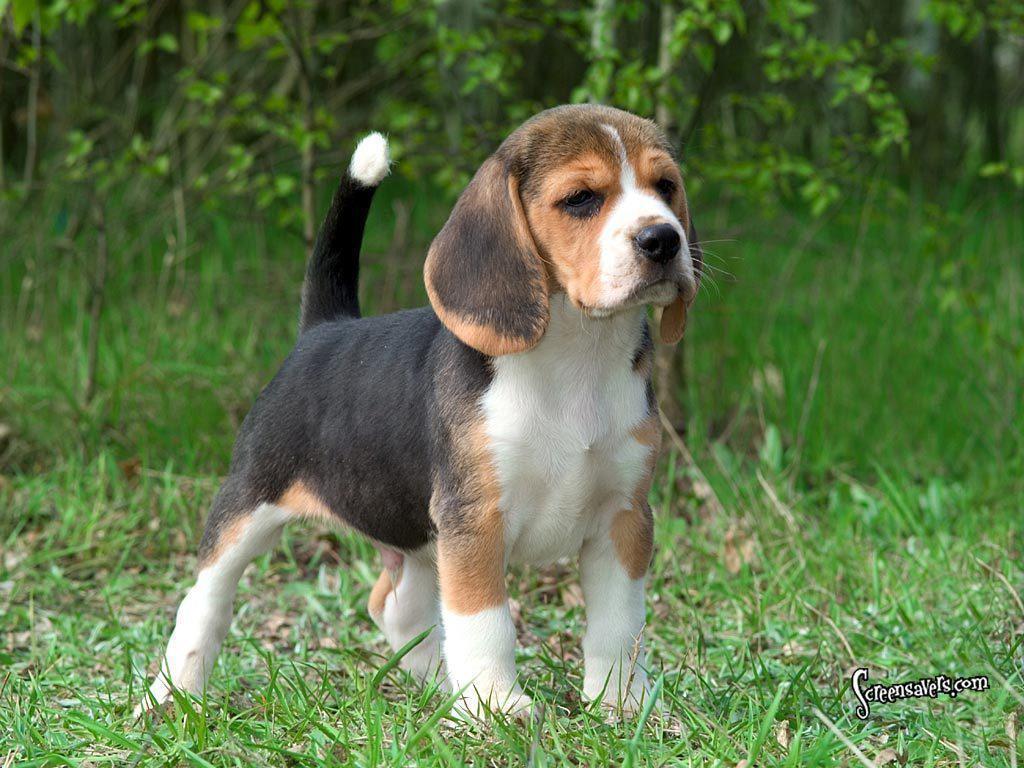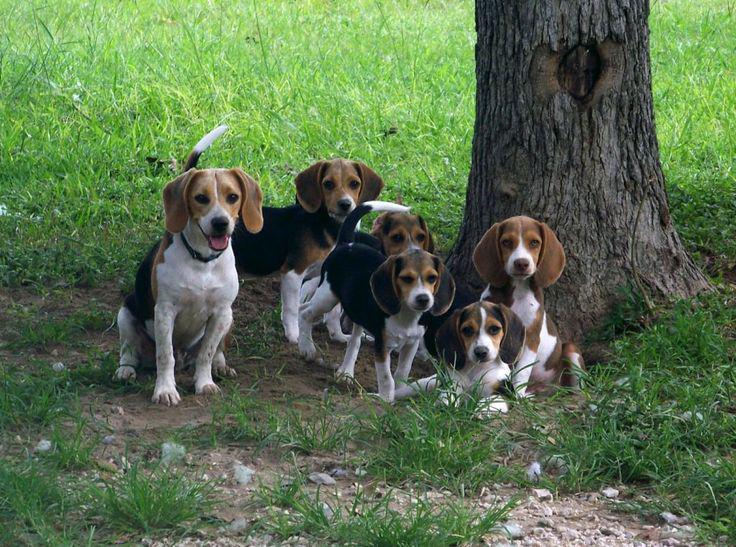The first image is the image on the left, the second image is the image on the right. Evaluate the accuracy of this statement regarding the images: "Four dogs are in the grass, and one has a red ball in its mouth.". Is it true? Answer yes or no. No. The first image is the image on the left, the second image is the image on the right. For the images displayed, is the sentence "There are more than one beagle in the image on the right" factually correct? Answer yes or no. Yes. 